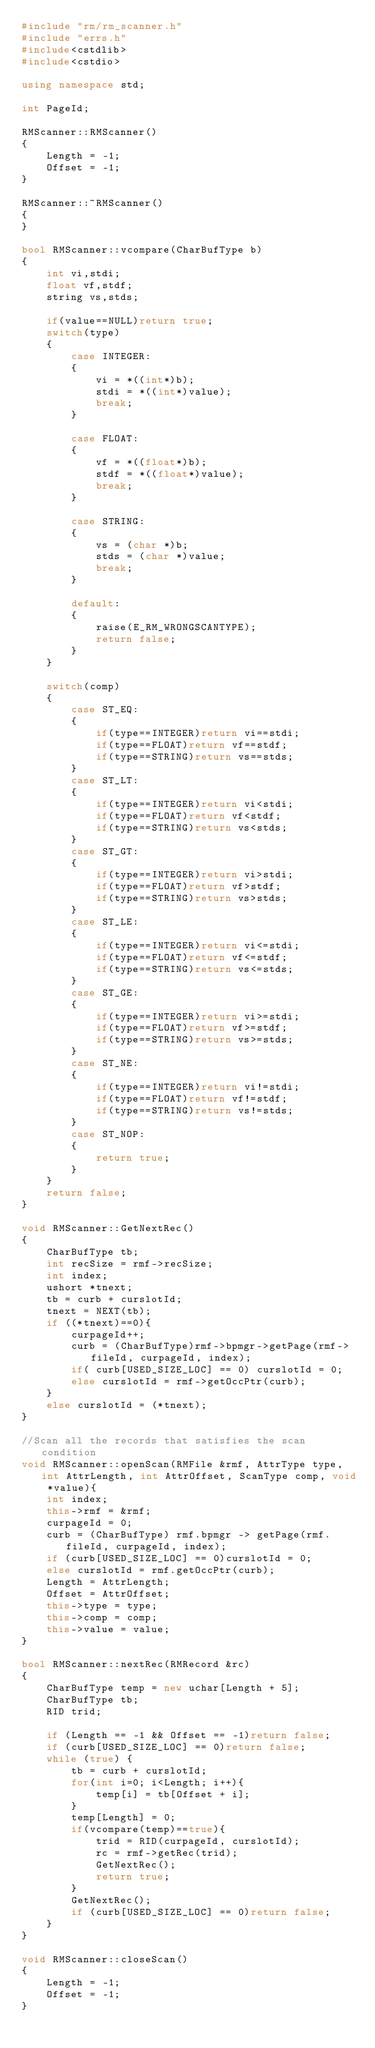Convert code to text. <code><loc_0><loc_0><loc_500><loc_500><_C++_>#include "rm/rm_scanner.h"
#include "errs.h"
#include<cstdlib>
#include<cstdio>

using namespace std;

int PageId;

RMScanner::RMScanner()
{
    Length = -1;
    Offset = -1;
}

RMScanner::~RMScanner()
{
}

bool RMScanner::vcompare(CharBufType b)
{
    int vi,stdi;
    float vf,stdf;
    string vs,stds;
    
    if(value==NULL)return true;
    switch(type)
    {
        case INTEGER:
        {
            vi = *((int*)b);
            stdi = *((int*)value);
            break;
        }
        
        case FLOAT:
        {
            vf = *((float*)b);
            stdf = *((float*)value);
            break;
        }
        
        case STRING:
        {
            vs = (char *)b;
            stds = (char *)value;
            break;
        }
        
        default:
        {
            raise(E_RM_WRONGSCANTYPE);
            return false;
        }
    }
    
    switch(comp)
    {
        case ST_EQ:
        {
            if(type==INTEGER)return vi==stdi;
            if(type==FLOAT)return vf==stdf;
            if(type==STRING)return vs==stds;
        }
        case ST_LT:
        {
            if(type==INTEGER)return vi<stdi;
            if(type==FLOAT)return vf<stdf;
            if(type==STRING)return vs<stds;
        }
        case ST_GT:
        {
            if(type==INTEGER)return vi>stdi;
            if(type==FLOAT)return vf>stdf;
            if(type==STRING)return vs>stds;
        }
        case ST_LE:
        {
            if(type==INTEGER)return vi<=stdi;
            if(type==FLOAT)return vf<=stdf;
            if(type==STRING)return vs<=stds;
        }
        case ST_GE:
        {
            if(type==INTEGER)return vi>=stdi;
            if(type==FLOAT)return vf>=stdf;
            if(type==STRING)return vs>=stds;
        }
        case ST_NE:
        {
            if(type==INTEGER)return vi!=stdi;
            if(type==FLOAT)return vf!=stdf;
            if(type==STRING)return vs!=stds;
        }
        case ST_NOP:
        {
            return true;
        }
    }
    return false;
}

void RMScanner::GetNextRec()
{
    CharBufType tb;
    int recSize = rmf->recSize;
    int index;
    ushort *tnext;
    tb = curb + curslotId;
    tnext = NEXT(tb);
    if ((*tnext)==0){
        curpageId++;
        curb = (CharBufType)rmf->bpmgr->getPage(rmf->fileId, curpageId, index);
        if( curb[USED_SIZE_LOC] == 0) curslotId = 0;
        else curslotId = rmf->getOccPtr(curb);
    }
    else curslotId = (*tnext);
}

//Scan all the records that satisfies the scan condition
void RMScanner::openScan(RMFile &rmf, AttrType type, int AttrLength, int AttrOffset, ScanType comp, void *value){
    int index;
    this->rmf = &rmf;
    curpageId = 0;
    curb = (CharBufType) rmf.bpmgr -> getPage(rmf.fileId, curpageId, index);
    if (curb[USED_SIZE_LOC] == 0)curslotId = 0;
    else curslotId = rmf.getOccPtr(curb);
    Length = AttrLength;
    Offset = AttrOffset;
    this->type = type;
    this->comp = comp;
    this->value = value;
}

bool RMScanner::nextRec(RMRecord &rc)
{
    CharBufType temp = new uchar[Length + 5];
    CharBufType tb;
    RID trid;

    if (Length == -1 && Offset == -1)return false;
    if (curb[USED_SIZE_LOC] == 0)return false;
    while (true) {
        tb = curb + curslotId;
        for(int i=0; i<Length; i++){
            temp[i] = tb[Offset + i];
        }
        temp[Length] = 0;
        if(vcompare(temp)==true){
            trid = RID(curpageId, curslotId);
            rc = rmf->getRec(trid);
            GetNextRec();
            return true;
        }
        GetNextRec();
        if (curb[USED_SIZE_LOC] == 0)return false;
    }
}

void RMScanner::closeScan()
{
    Length = -1;
    Offset = -1;
}</code> 